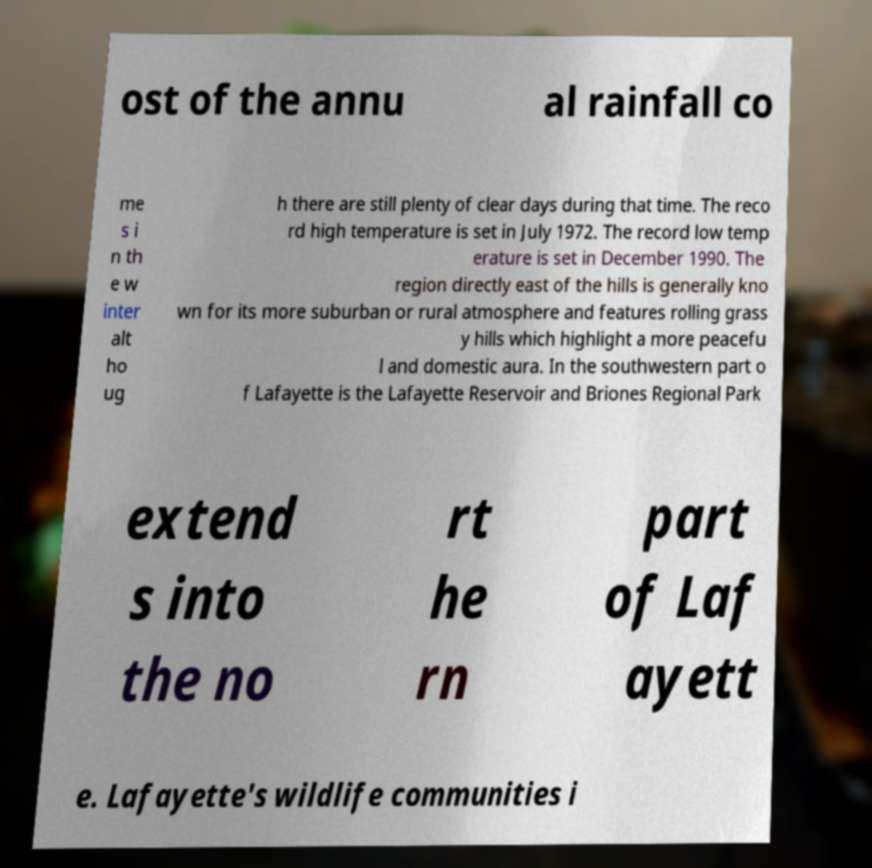Can you read and provide the text displayed in the image?This photo seems to have some interesting text. Can you extract and type it out for me? ost of the annu al rainfall co me s i n th e w inter alt ho ug h there are still plenty of clear days during that time. The reco rd high temperature is set in July 1972. The record low temp erature is set in December 1990. The region directly east of the hills is generally kno wn for its more suburban or rural atmosphere and features rolling grass y hills which highlight a more peacefu l and domestic aura. In the southwestern part o f Lafayette is the Lafayette Reservoir and Briones Regional Park extend s into the no rt he rn part of Laf ayett e. Lafayette's wildlife communities i 